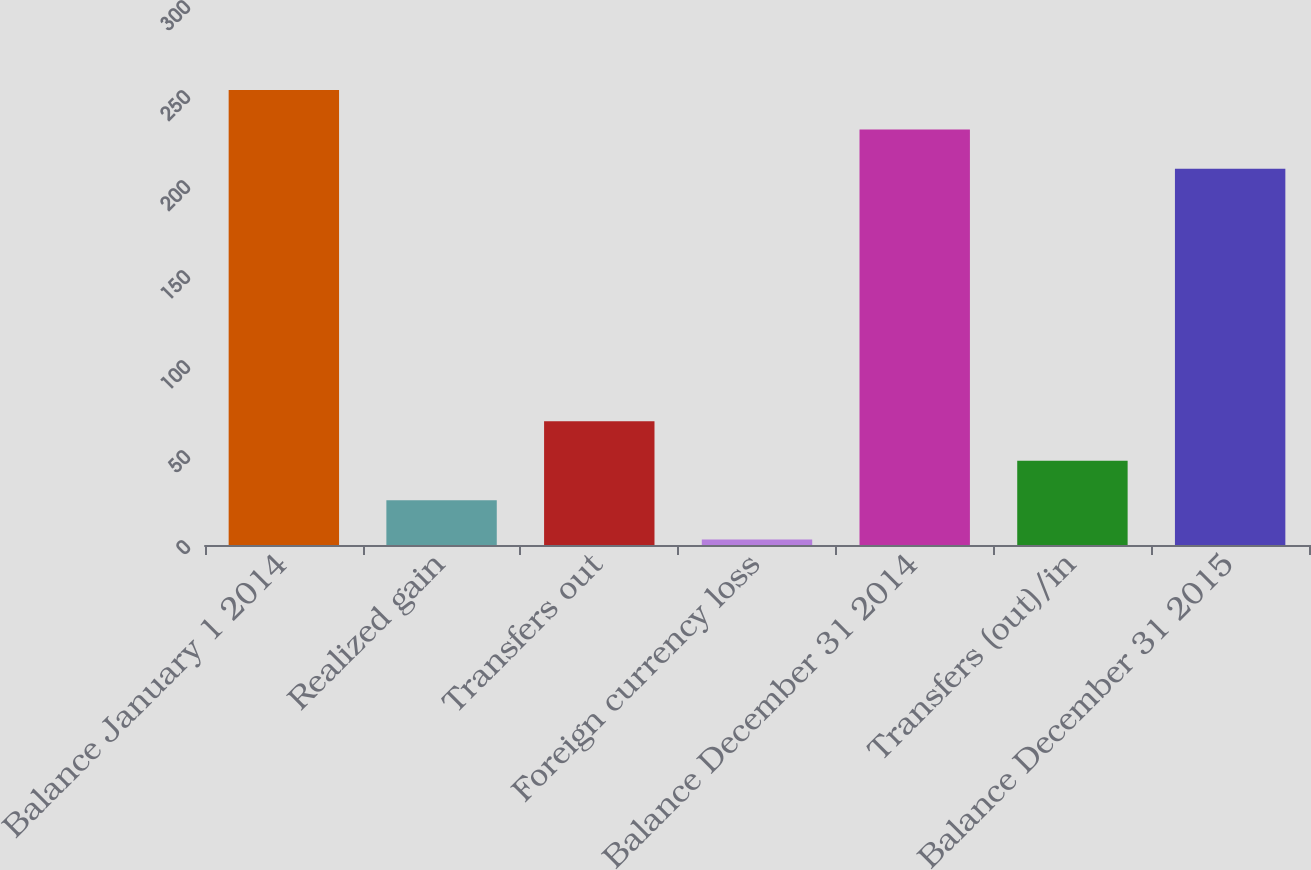Convert chart. <chart><loc_0><loc_0><loc_500><loc_500><bar_chart><fcel>Balance January 1 2014<fcel>Realized gain<fcel>Transfers out<fcel>Foreign currency loss<fcel>Balance December 31 2014<fcel>Transfers (out)/in<fcel>Balance December 31 2015<nl><fcel>252.8<fcel>24.9<fcel>68.7<fcel>3<fcel>230.9<fcel>46.8<fcel>209<nl></chart> 